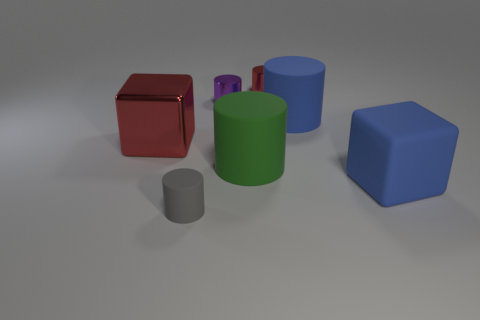Subtract all purple cylinders. How many cylinders are left? 4 Subtract 1 cylinders. How many cylinders are left? 4 Subtract all purple cylinders. How many cylinders are left? 4 Subtract all cyan blocks. Subtract all green cylinders. How many blocks are left? 2 Add 1 blue rubber objects. How many objects exist? 8 Subtract all cylinders. How many objects are left? 2 Subtract 0 cyan cylinders. How many objects are left? 7 Subtract all big objects. Subtract all large shiny cubes. How many objects are left? 2 Add 4 red metal objects. How many red metal objects are left? 6 Add 6 gray rubber cylinders. How many gray rubber cylinders exist? 7 